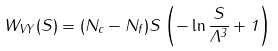<formula> <loc_0><loc_0><loc_500><loc_500>W _ { V Y } ( S ) = ( N _ { c } - N _ { f } ) S \left ( - \ln \frac { S } { \Lambda ^ { 3 } } + 1 \right )</formula> 